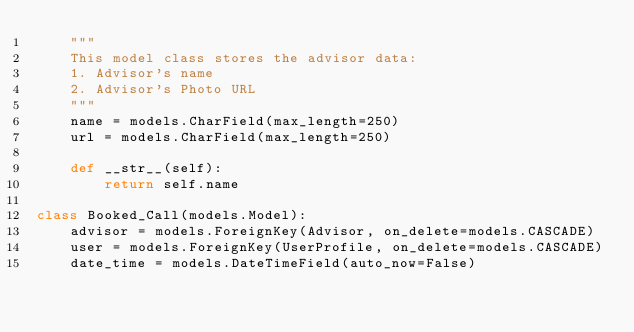<code> <loc_0><loc_0><loc_500><loc_500><_Python_>    """
    This model class stores the advisor data:
    1. Advisor's name
    2. Advisor's Photo URL
    """
    name = models.CharField(max_length=250)
    url = models.CharField(max_length=250)

    def __str__(self):
        return self.name

class Booked_Call(models.Model):
    advisor = models.ForeignKey(Advisor, on_delete=models.CASCADE)
    user = models.ForeignKey(UserProfile, on_delete=models.CASCADE)
    date_time = models.DateTimeField(auto_now=False)</code> 